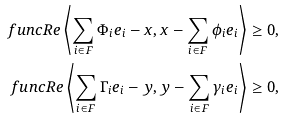Convert formula to latex. <formula><loc_0><loc_0><loc_500><loc_500>\ f u n c { R e } \left \langle \sum _ { i \in F } \Phi _ { i } e _ { i } - x , x - \sum _ { i \in F } \phi _ { i } e _ { i } \right \rangle & \geq 0 , \\ \ f u n c { R e } \left \langle \sum _ { i \in F } \Gamma _ { i } e _ { i } - y , y - \sum _ { i \in F } \gamma _ { i } e _ { i } \right \rangle & \geq 0 ,</formula> 